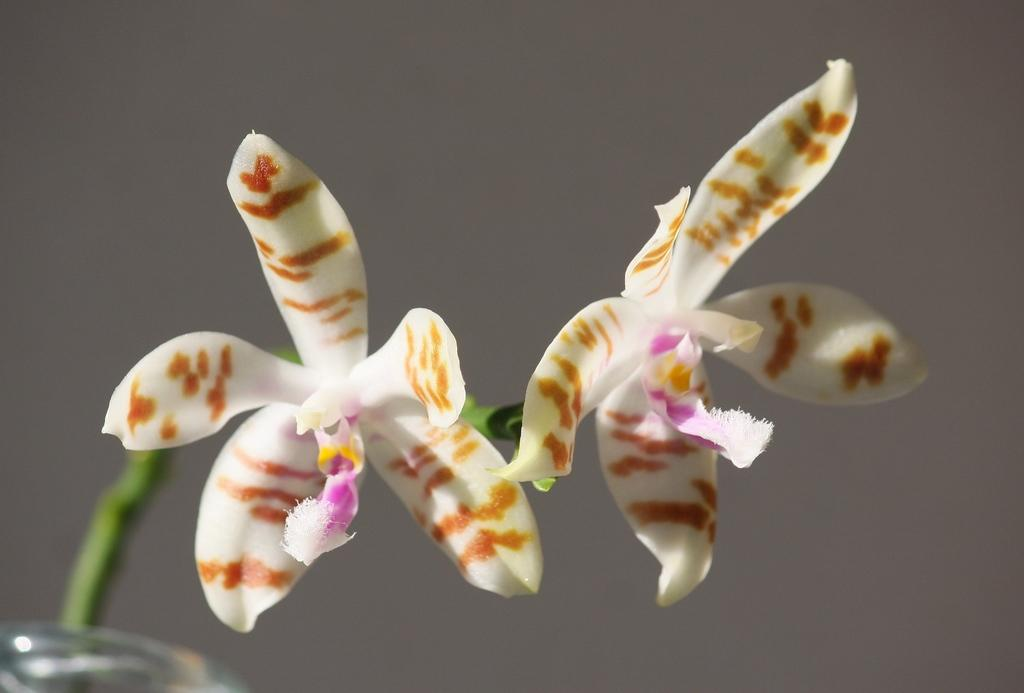What are the main subjects in the center of the image? There are two white color flowers in the center of the image. What color are the stems of the flowers? The flowers have green color stems. Can you describe any other objects visible in the image? There are other objects visible in the background of the image, but their specific details are not mentioned in the provided facts. Can you see the ocean in the background of the image? There is no mention of an ocean or any water body in the provided facts, so it cannot be determined if it is present in the image. 